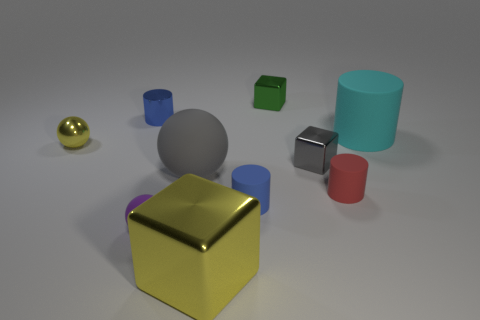Subtract all tiny shiny blocks. How many blocks are left? 1 Subtract 1 balls. How many balls are left? 2 Subtract all purple spheres. How many spheres are left? 2 Subtract all cyan balls. Subtract all purple cubes. How many balls are left? 3 Subtract all purple spheres. How many cyan cylinders are left? 1 Subtract all cylinders. How many objects are left? 6 Subtract all green matte cylinders. Subtract all small rubber cylinders. How many objects are left? 8 Add 1 tiny red cylinders. How many tiny red cylinders are left? 2 Add 9 big yellow cubes. How many big yellow cubes exist? 10 Subtract 1 green blocks. How many objects are left? 9 